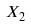Convert formula to latex. <formula><loc_0><loc_0><loc_500><loc_500>X _ { 2 }</formula> 